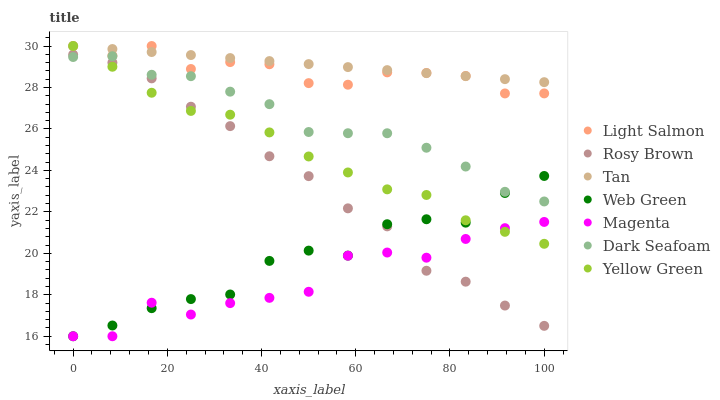Does Magenta have the minimum area under the curve?
Answer yes or no. Yes. Does Tan have the maximum area under the curve?
Answer yes or no. Yes. Does Yellow Green have the minimum area under the curve?
Answer yes or no. No. Does Yellow Green have the maximum area under the curve?
Answer yes or no. No. Is Tan the smoothest?
Answer yes or no. Yes. Is Magenta the roughest?
Answer yes or no. Yes. Is Yellow Green the smoothest?
Answer yes or no. No. Is Yellow Green the roughest?
Answer yes or no. No. Does Web Green have the lowest value?
Answer yes or no. Yes. Does Yellow Green have the lowest value?
Answer yes or no. No. Does Tan have the highest value?
Answer yes or no. Yes. Does Rosy Brown have the highest value?
Answer yes or no. No. Is Magenta less than Tan?
Answer yes or no. Yes. Is Light Salmon greater than Dark Seafoam?
Answer yes or no. Yes. Does Yellow Green intersect Rosy Brown?
Answer yes or no. Yes. Is Yellow Green less than Rosy Brown?
Answer yes or no. No. Is Yellow Green greater than Rosy Brown?
Answer yes or no. No. Does Magenta intersect Tan?
Answer yes or no. No. 